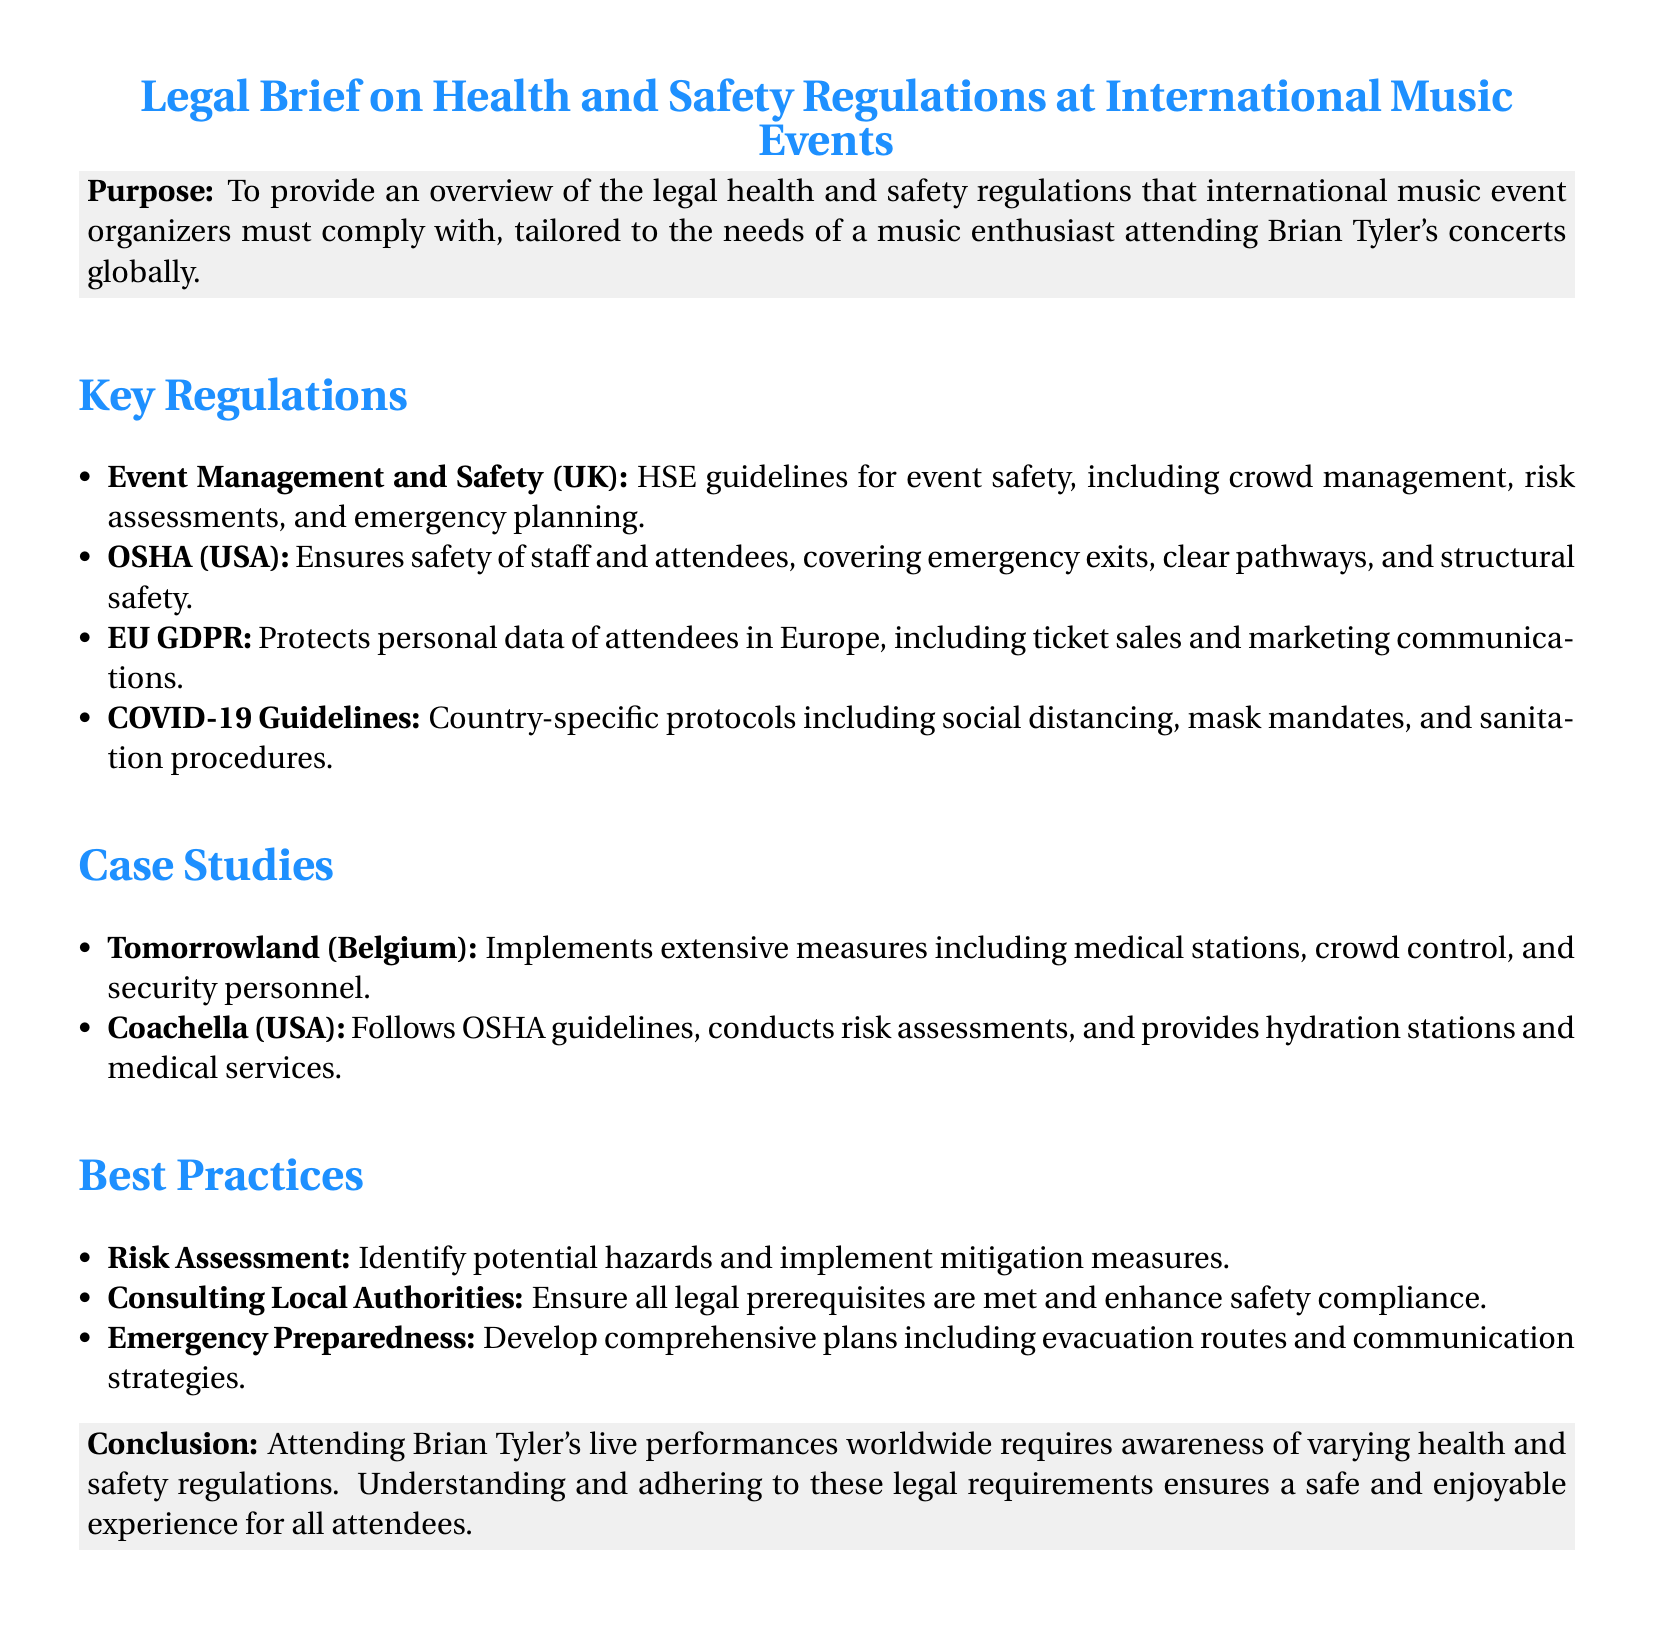What are the HSE guidelines focused on? HSE guidelines focus on event safety, including crowd management, risk assessments, and emergency planning.
Answer: Event safety What does OSHA ensure at music events? OSHA ensures the safety of staff and attendees, covering emergency exits, clear pathways, and structural safety.
Answer: Safety of staff and attendees What country-specific regulations are mentioned? The document mentions COVID-19 guidelines which include social distancing, mask mandates, and sanitation procedures.
Answer: COVID-19 guidelines Which music event is referenced as a case study? Tomorrowland (Belgium) and Coachella (USA) are referenced as case studies in the document.
Answer: Tomorrowland and Coachella What is a recommended best practice for event organizers? A recommended best practice is conducting a risk assessment to identify potential hazards.
Answer: Risk assessment What legal prerequisite should organizers consult? Organizers should consult local authorities to ensure all legal prerequisites are met.
Answer: Local authorities What does the conclusion emphasize for attendees? The conclusion emphasizes the importance of understanding varying health and safety regulations.
Answer: Awareness of regulations How many case studies are included in the document? There are two case studies mentioned in the document.
Answer: Two What color is used for section headings? The section headings are styled in music blue color.
Answer: Music blue 